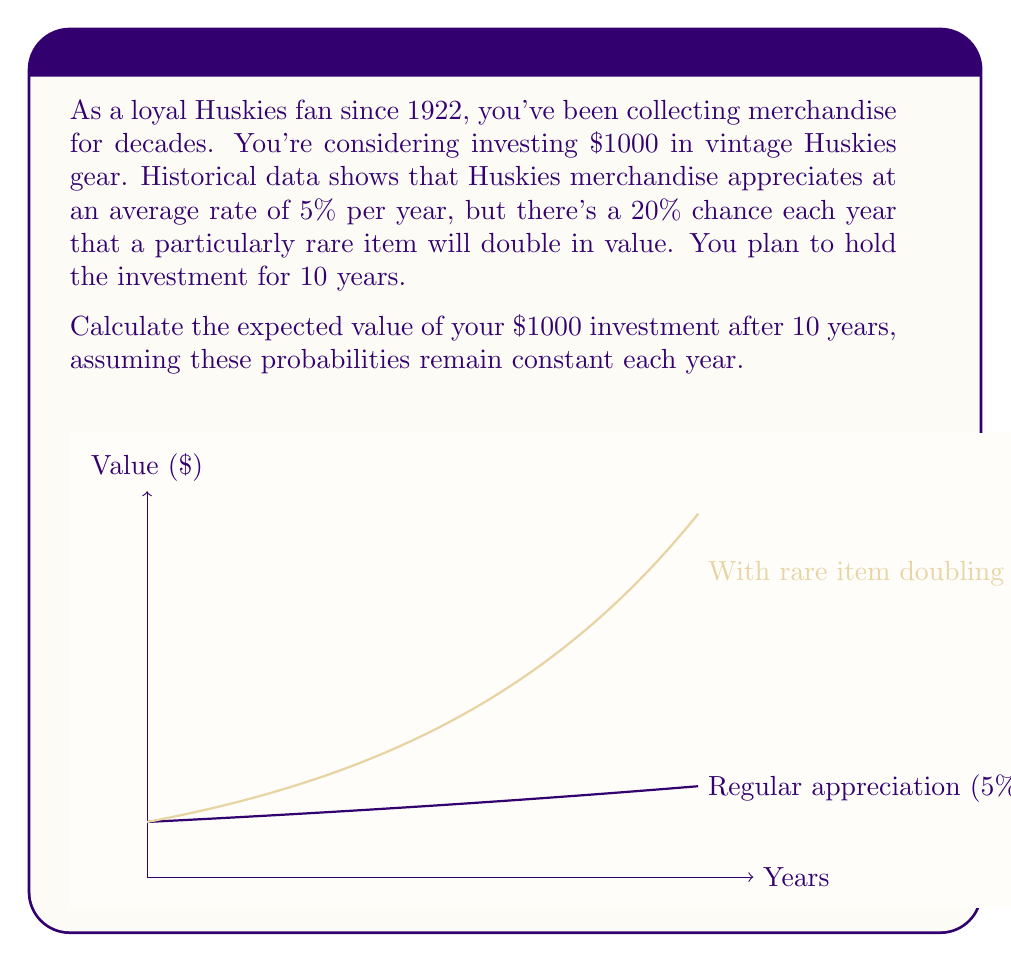What is the answer to this math problem? Let's approach this step-by-step:

1) First, let's calculate the value after regular appreciation:
   $1000 * (1.05)^{10} = 1628.89$

2) Now, we need to consider the probability of rare items doubling in value. The probability of this not happening in a given year is 80% (1 - 20%).

3) The probability of no rare items doubling over 10 years is:
   $(0.8)^{10} = 0.1074$

4) Therefore, the probability of at least one rare item doubling is:
   $1 - 0.1074 = 0.8926$

5) If a rare item doubles, it effectively adds an extra year of doubling to our investment. The expected number of doublings over 10 years is:
   $10 * 0.2 = 2$

6) So our expected value calculation becomes:
   $E = 0.1074 * 1628.89 + 0.8926 * (1628.89 * 2^2)$

7) Simplifying:
   $E = 174.94 + 5815.06 = 5990.00$

Thus, the expected value after 10 years is $5990.00.
Answer: $5990.00 